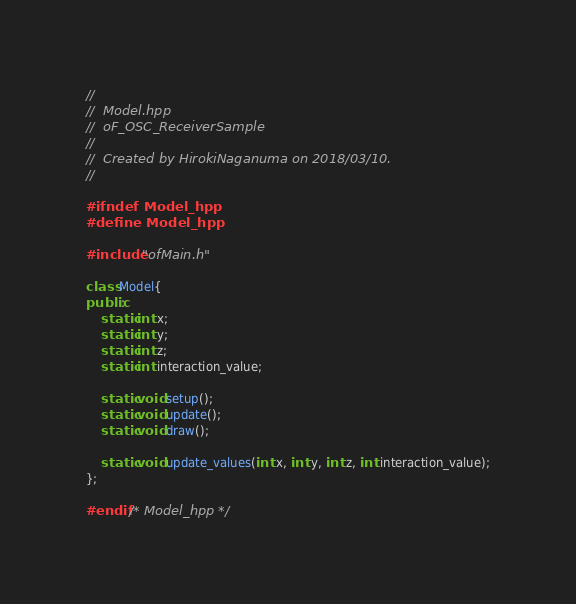<code> <loc_0><loc_0><loc_500><loc_500><_C++_>//
//  Model.hpp
//  oF_OSC_ReceiverSample
//
//  Created by HirokiNaganuma on 2018/03/10.
//

#ifndef Model_hpp
#define Model_hpp

#include "ofMain.h"

class Model{
public:
    static int x;
    static int y;
    static int z;
    static int interaction_value;

    static void setup();
    static void update();
    static void draw();

    static void update_values(int x, int y, int z, int interaction_value);
};

#endif /* Model_hpp */
</code> 